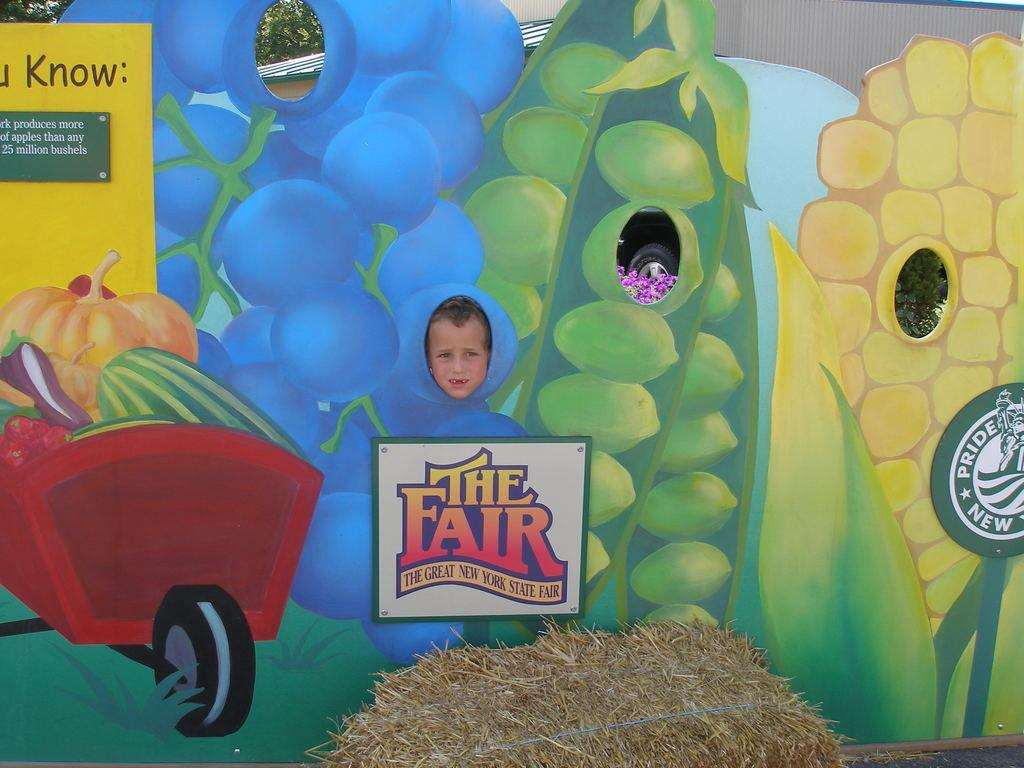What is the main subject of the image? There is a bundle of grass in the image. What else can be seen in the image besides the grass? There are boards, a kid standing near a board, a vehicle tire, a plant, flowers, a building, and trees in the image. How many girls are riding boats in the image? There are no girls or boats present in the image. What season is depicted in the image? The provided facts do not give any information about the season, so we cannot determine if it is summer or any other season. 